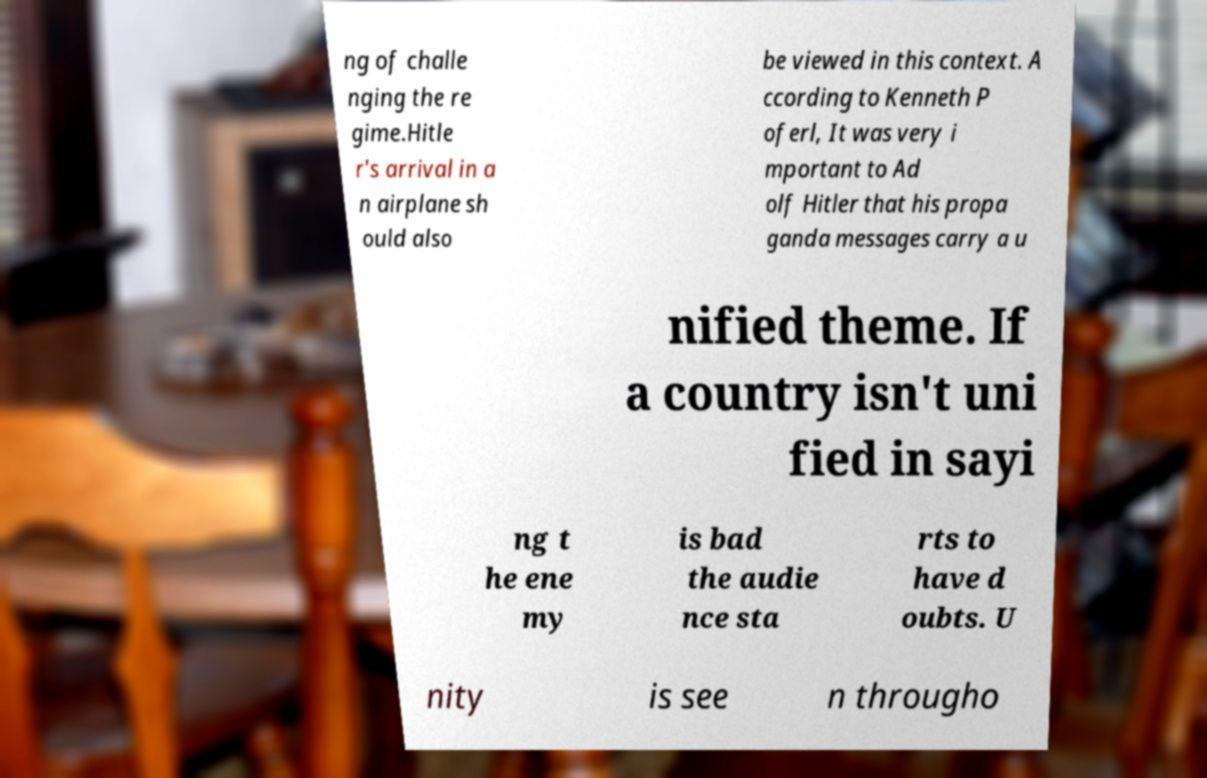Could you assist in decoding the text presented in this image and type it out clearly? ng of challe nging the re gime.Hitle r's arrival in a n airplane sh ould also be viewed in this context. A ccording to Kenneth P oferl, It was very i mportant to Ad olf Hitler that his propa ganda messages carry a u nified theme. If a country isn't uni fied in sayi ng t he ene my is bad the audie nce sta rts to have d oubts. U nity is see n througho 